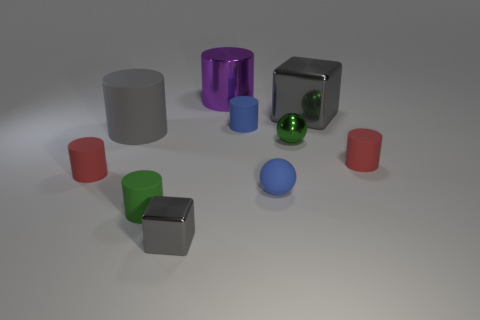What number of other objects are the same size as the blue cylinder?
Make the answer very short. 6. Are there an equal number of large purple cylinders left of the large purple object and gray metal things that are in front of the big gray cube?
Provide a short and direct response. No. There is a large shiny thing that is the same shape as the tiny gray object; what color is it?
Give a very brief answer. Gray. Is there anything else that has the same shape as the big gray metal thing?
Provide a short and direct response. Yes. Is the color of the matte object to the left of the gray cylinder the same as the metallic cylinder?
Provide a succinct answer. No. There is another gray metallic thing that is the same shape as the tiny gray thing; what size is it?
Offer a terse response. Large. How many tiny gray objects have the same material as the large purple cylinder?
Make the answer very short. 1. Is there a metallic thing in front of the object that is on the right side of the gray metallic thing that is on the right side of the metallic cylinder?
Make the answer very short. Yes. There is a small green metal object; what shape is it?
Provide a short and direct response. Sphere. Do the red object to the right of the blue cylinder and the small green object left of the tiny cube have the same material?
Keep it short and to the point. Yes. 